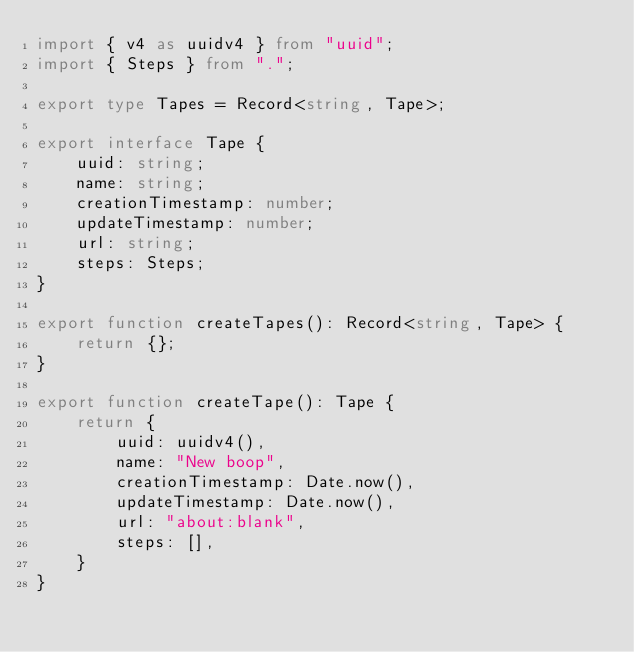<code> <loc_0><loc_0><loc_500><loc_500><_TypeScript_>import { v4 as uuidv4 } from "uuid";
import { Steps } from ".";

export type Tapes = Record<string, Tape>;

export interface Tape {
    uuid: string;
    name: string;
    creationTimestamp: number;
    updateTimestamp: number;
    url: string;
    steps: Steps;
}

export function createTapes(): Record<string, Tape> {
    return {};
}

export function createTape(): Tape {
    return {
        uuid: uuidv4(),
        name: "New boop",
        creationTimestamp: Date.now(),
        updateTimestamp: Date.now(),
        url: "about:blank",
        steps: [],
    }
}
</code> 